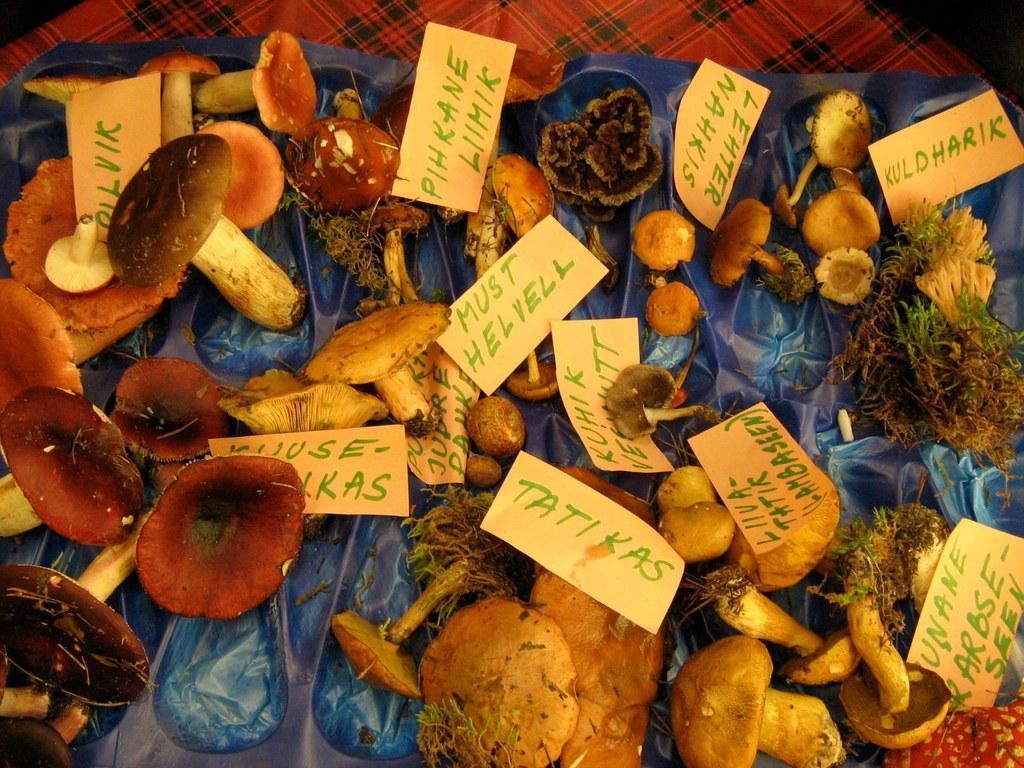Can you describe this image briefly? In this image I can see mushroom plants, papers on a plastic cover. This image is taken may be in a room. 